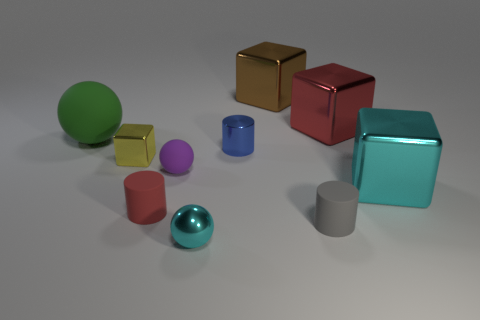Is there anything else that has the same shape as the big rubber object?
Provide a succinct answer. Yes. Is the material of the yellow cube the same as the cyan object that is to the right of the metal ball?
Provide a short and direct response. Yes. What color is the matte ball to the right of the large thing that is left of the red object that is left of the blue object?
Your answer should be compact. Purple. Does the small metallic sphere have the same color as the large object that is left of the tiny red rubber cylinder?
Provide a short and direct response. No. The large matte thing is what color?
Ensure brevity in your answer.  Green. What is the shape of the matte thing that is on the right side of the cyan metallic thing that is to the left of the matte cylinder right of the tiny red rubber thing?
Ensure brevity in your answer.  Cylinder. What number of other objects are there of the same color as the small metallic sphere?
Offer a very short reply. 1. Is the number of rubber balls that are left of the small yellow shiny cube greater than the number of blue objects that are to the right of the red metallic object?
Offer a terse response. Yes. Are there any red metal cubes in front of the red cylinder?
Provide a succinct answer. No. What is the material of the tiny cylinder that is both in front of the purple sphere and right of the shiny ball?
Your answer should be compact. Rubber. 